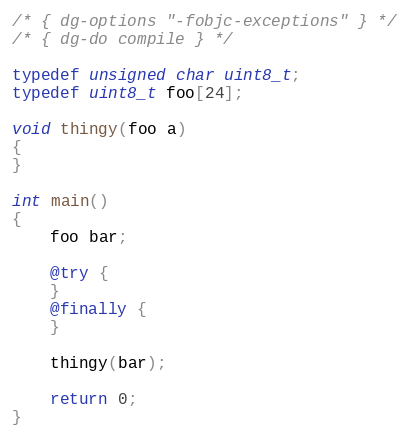Convert code to text. <code><loc_0><loc_0><loc_500><loc_500><_ObjectiveC_>/* { dg-options "-fobjc-exceptions" } */
/* { dg-do compile } */

typedef unsigned char uint8_t;
typedef uint8_t foo[24];

void thingy(foo a)
{
}

int main()
{
    foo bar;

    @try {
    } 
    @finally {
    }

    thingy(bar);

    return 0;
}

</code> 